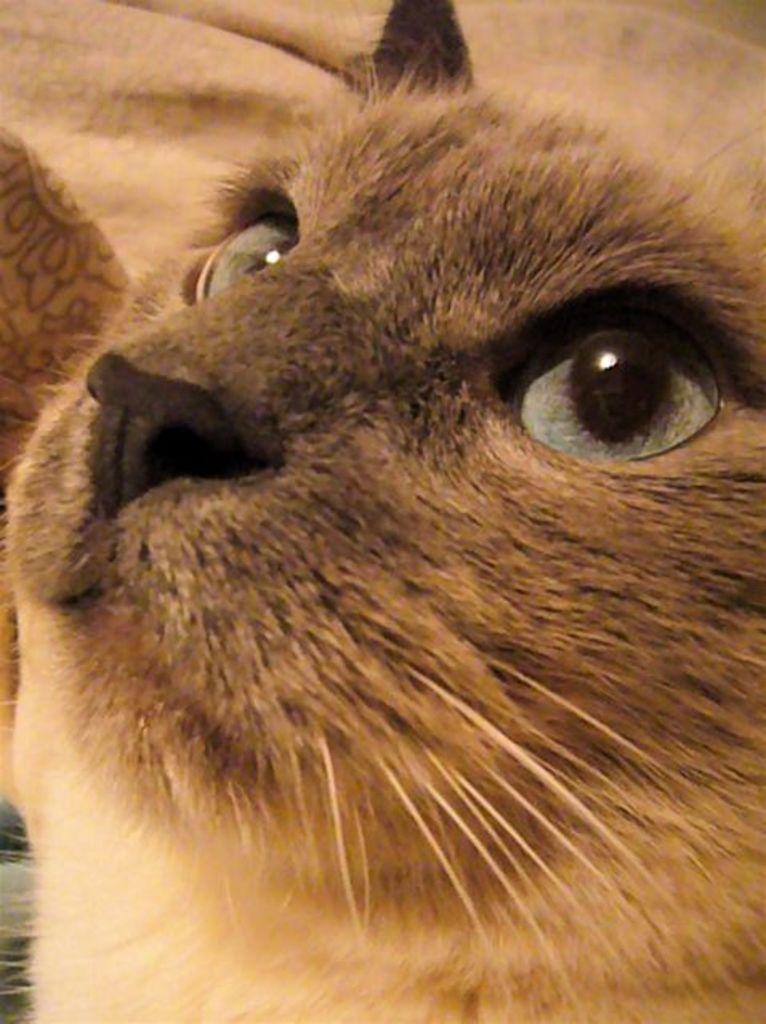Describe this image in one or two sentences. In this image we can see a cat. In the background there is cloth. 